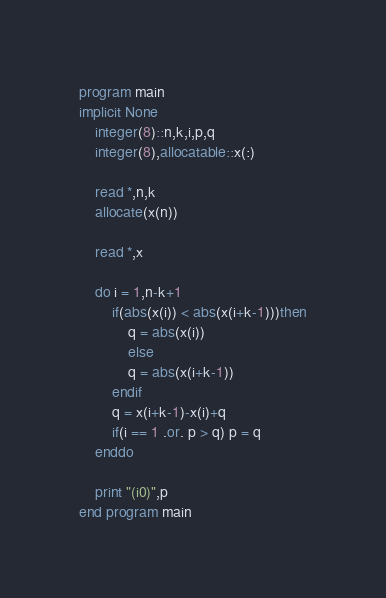Convert code to text. <code><loc_0><loc_0><loc_500><loc_500><_FORTRAN_>program main
implicit None
	integer(8)::n,k,i,p,q
	integer(8),allocatable::x(:)
	
	read *,n,k
	allocate(x(n))
	
	read *,x
	
	do i = 1,n-k+1
		if(abs(x(i)) < abs(x(i+k-1)))then
			q = abs(x(i))
			else
			q = abs(x(i+k-1))
		endif
		q = x(i+k-1)-x(i)+q
		if(i == 1 .or. p > q) p = q
	enddo
	
	print "(i0)",p
end program main</code> 